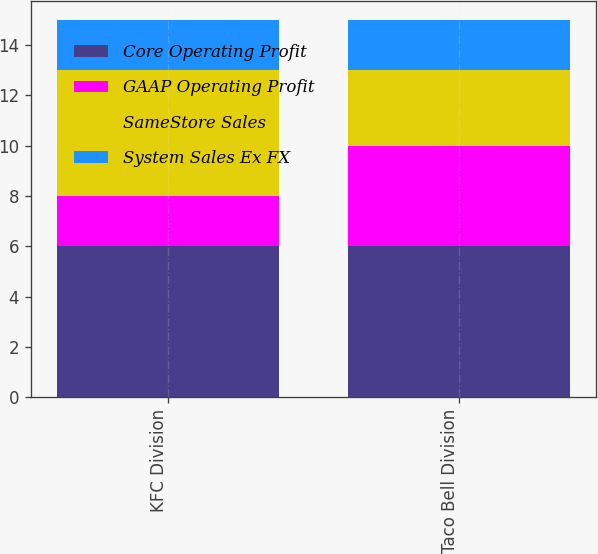Convert chart. <chart><loc_0><loc_0><loc_500><loc_500><stacked_bar_chart><ecel><fcel>KFC Division<fcel>Taco Bell Division<nl><fcel>Core Operating Profit<fcel>6<fcel>6<nl><fcel>GAAP Operating Profit<fcel>2<fcel>4<nl><fcel>SameStore Sales<fcel>5<fcel>3<nl><fcel>System Sales Ex FX<fcel>2<fcel>2<nl></chart> 